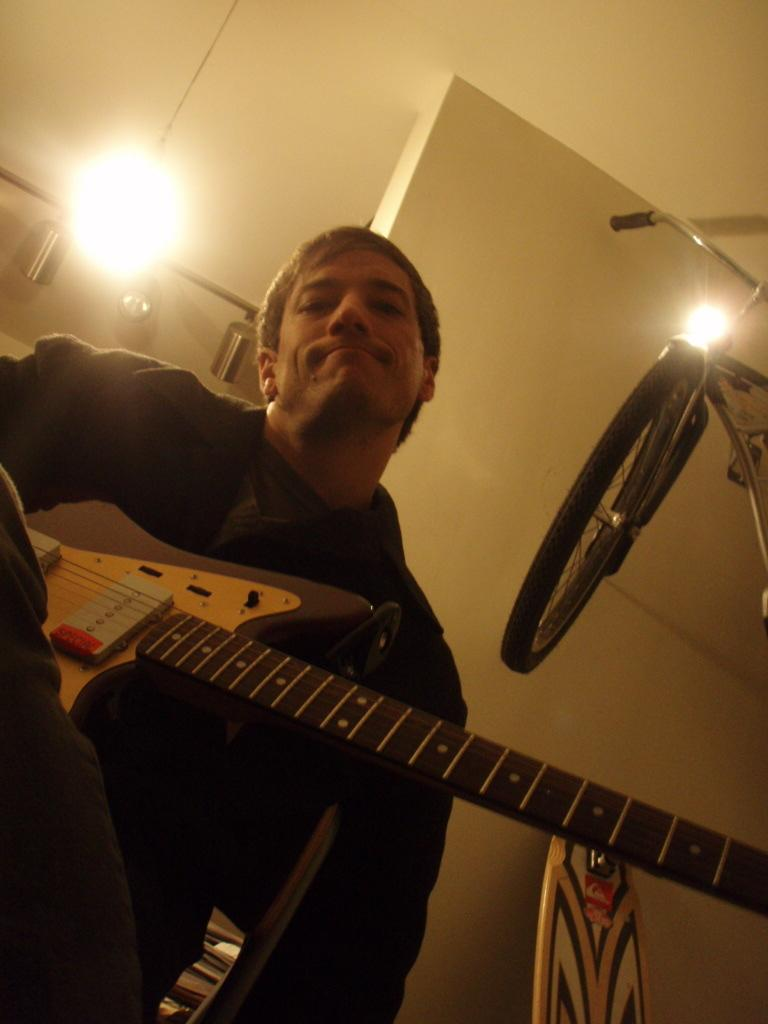What is the main subject of the image? The main subject of the image is a man. What is the man doing in the image? The man is standing in the image. What object is the man holding in his hand? The man is holding a guitar in his hand. How many houses can be seen in the image? There are no houses visible in the image; it features a man standing and holding a guitar. Is the man's father present in the image? There is no information about the man's father in the image, as it only shows the man standing and holding a guitar. 